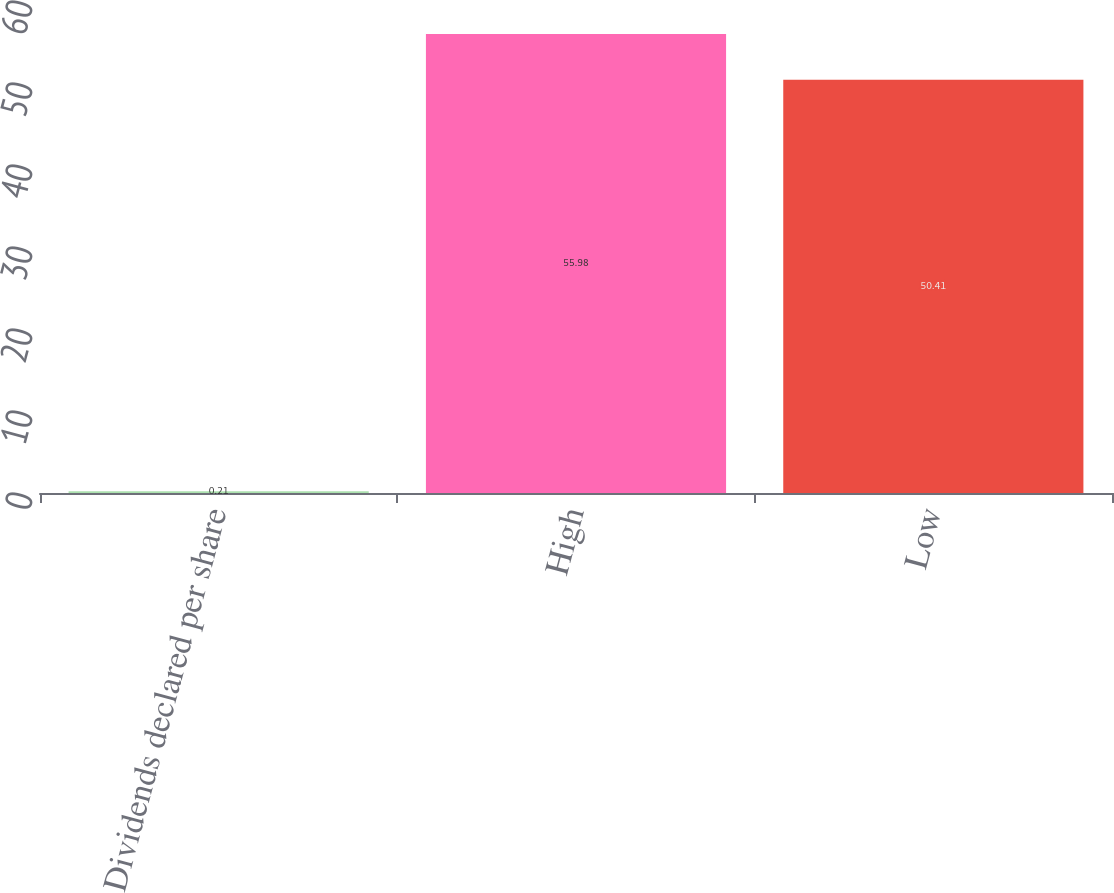Convert chart. <chart><loc_0><loc_0><loc_500><loc_500><bar_chart><fcel>Dividends declared per share<fcel>High<fcel>Low<nl><fcel>0.21<fcel>55.98<fcel>50.41<nl></chart> 